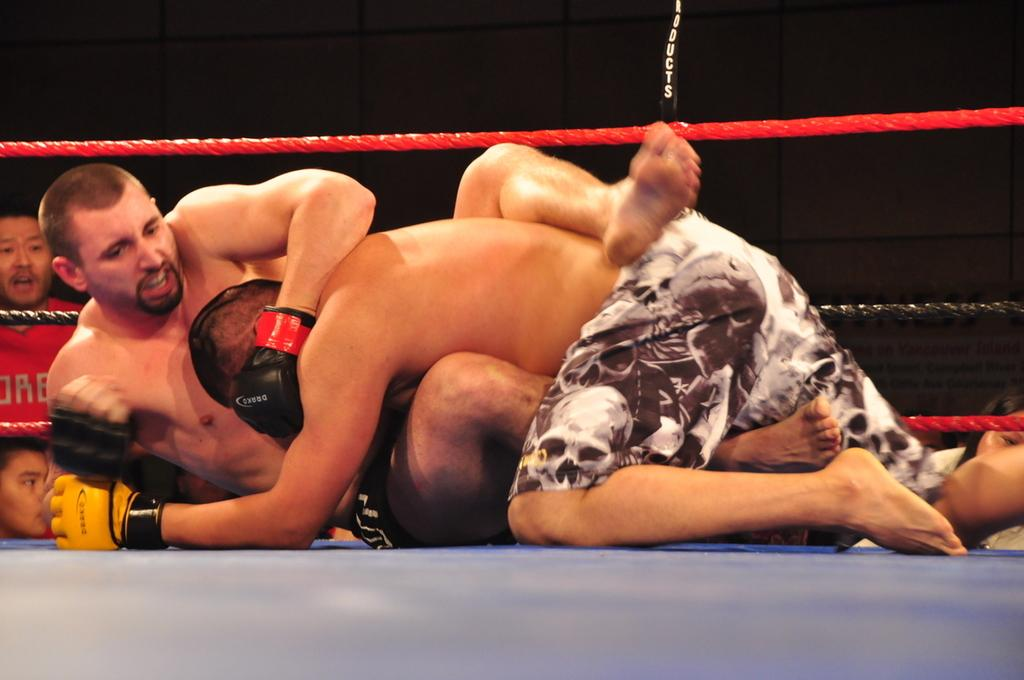What is the main subject of the image? The image depicts a professional boxing match. How many people are participating in the match? There are two people participating in the match. Can you describe any additional elements in the image? There are two images of other people visible in the background. What type of coat is the referee wearing in the image? There is no referee present in the image, and therefore no coat can be observed. 